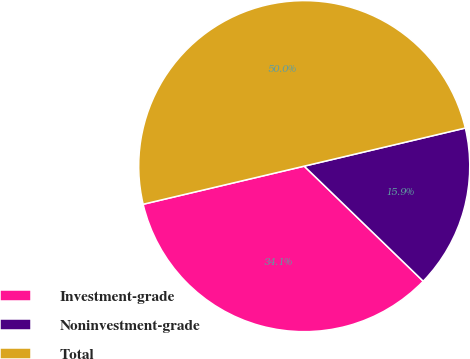<chart> <loc_0><loc_0><loc_500><loc_500><pie_chart><fcel>Investment-grade<fcel>Noninvestment-grade<fcel>Total<nl><fcel>34.07%<fcel>15.93%<fcel>50.0%<nl></chart> 